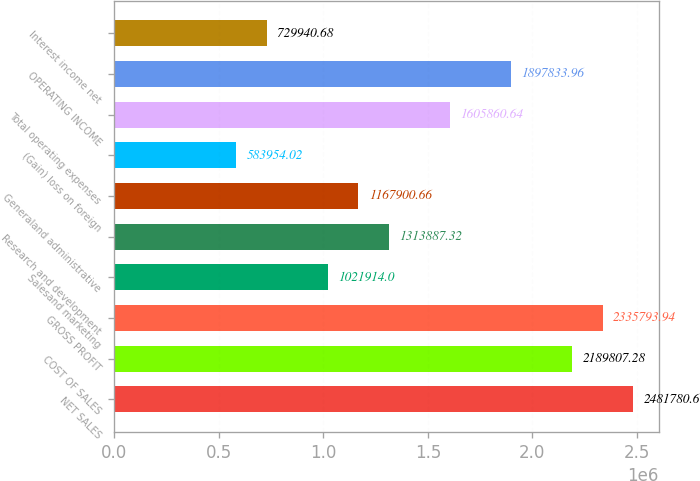Convert chart. <chart><loc_0><loc_0><loc_500><loc_500><bar_chart><fcel>NET SALES<fcel>COST OF SALES<fcel>GROSS PROFIT<fcel>Salesand marketing<fcel>Research and development<fcel>Generaland administrative<fcel>(Gain) loss on foreign<fcel>Total operating expenses<fcel>OPERATING INCOME<fcel>Interest income net<nl><fcel>2.48178e+06<fcel>2.18981e+06<fcel>2.33579e+06<fcel>1.02191e+06<fcel>1.31389e+06<fcel>1.1679e+06<fcel>583954<fcel>1.60586e+06<fcel>1.89783e+06<fcel>729941<nl></chart> 